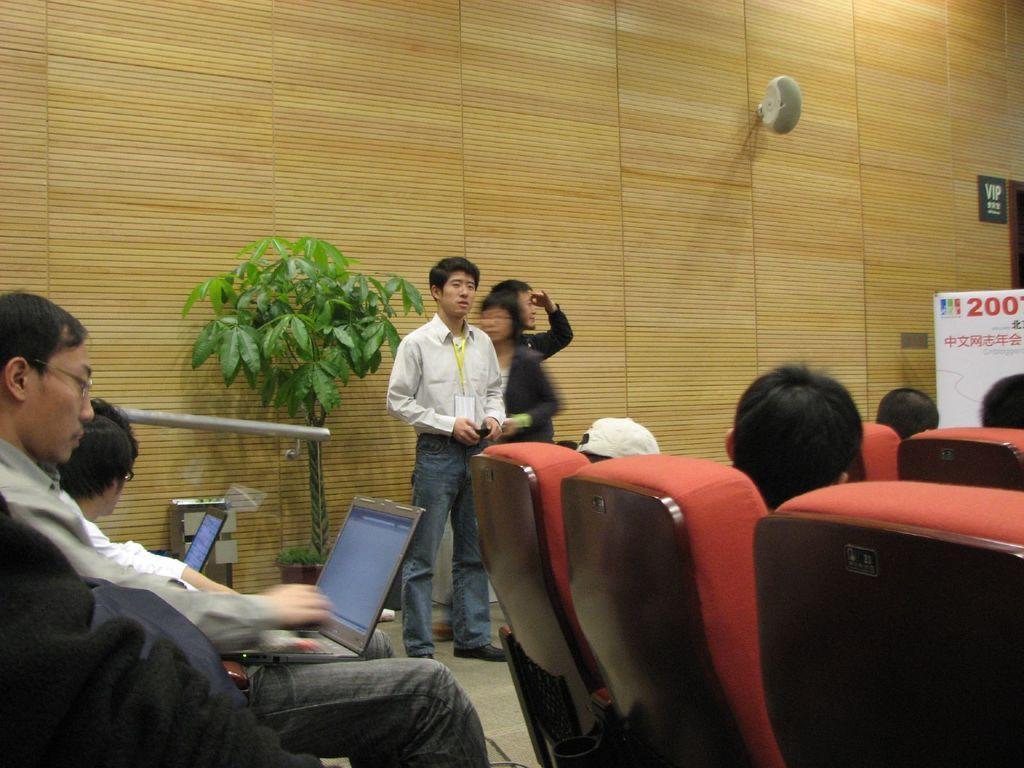Please provide a concise description of this image. In the center of the image we can see a man standing, next to him there are two people. At the bottom we can see people sitting on the chairs. On the left there are laptops. In the background there is a plant, a board, speaker and a wall. 